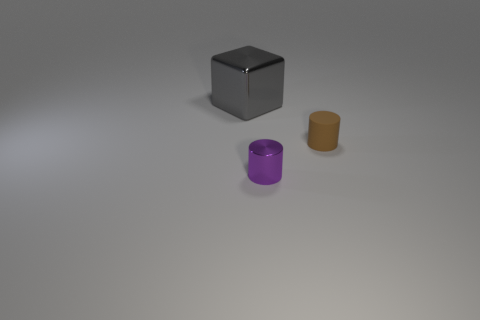Add 2 small shiny cylinders. How many objects exist? 5 Subtract all cylinders. How many objects are left? 1 Add 3 small metal cylinders. How many small metal cylinders are left? 4 Add 1 small purple things. How many small purple things exist? 2 Subtract 1 brown cylinders. How many objects are left? 2 Subtract all large cyan shiny blocks. Subtract all cylinders. How many objects are left? 1 